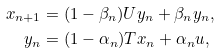Convert formula to latex. <formula><loc_0><loc_0><loc_500><loc_500>x _ { n + 1 } & = ( 1 - \beta _ { n } ) U y _ { n } + \beta _ { n } y _ { n } , \\ y _ { n } & = ( 1 - \alpha _ { n } ) T x _ { n } + \alpha _ { n } u ,</formula> 